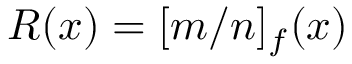<formula> <loc_0><loc_0><loc_500><loc_500>R ( x ) = [ m / n ] _ { f } ( x )</formula> 